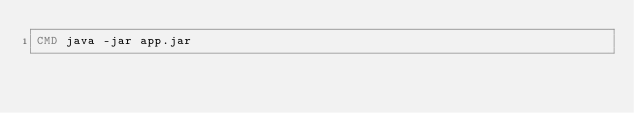<code> <loc_0><loc_0><loc_500><loc_500><_Dockerfile_>CMD java -jar app.jar
</code> 